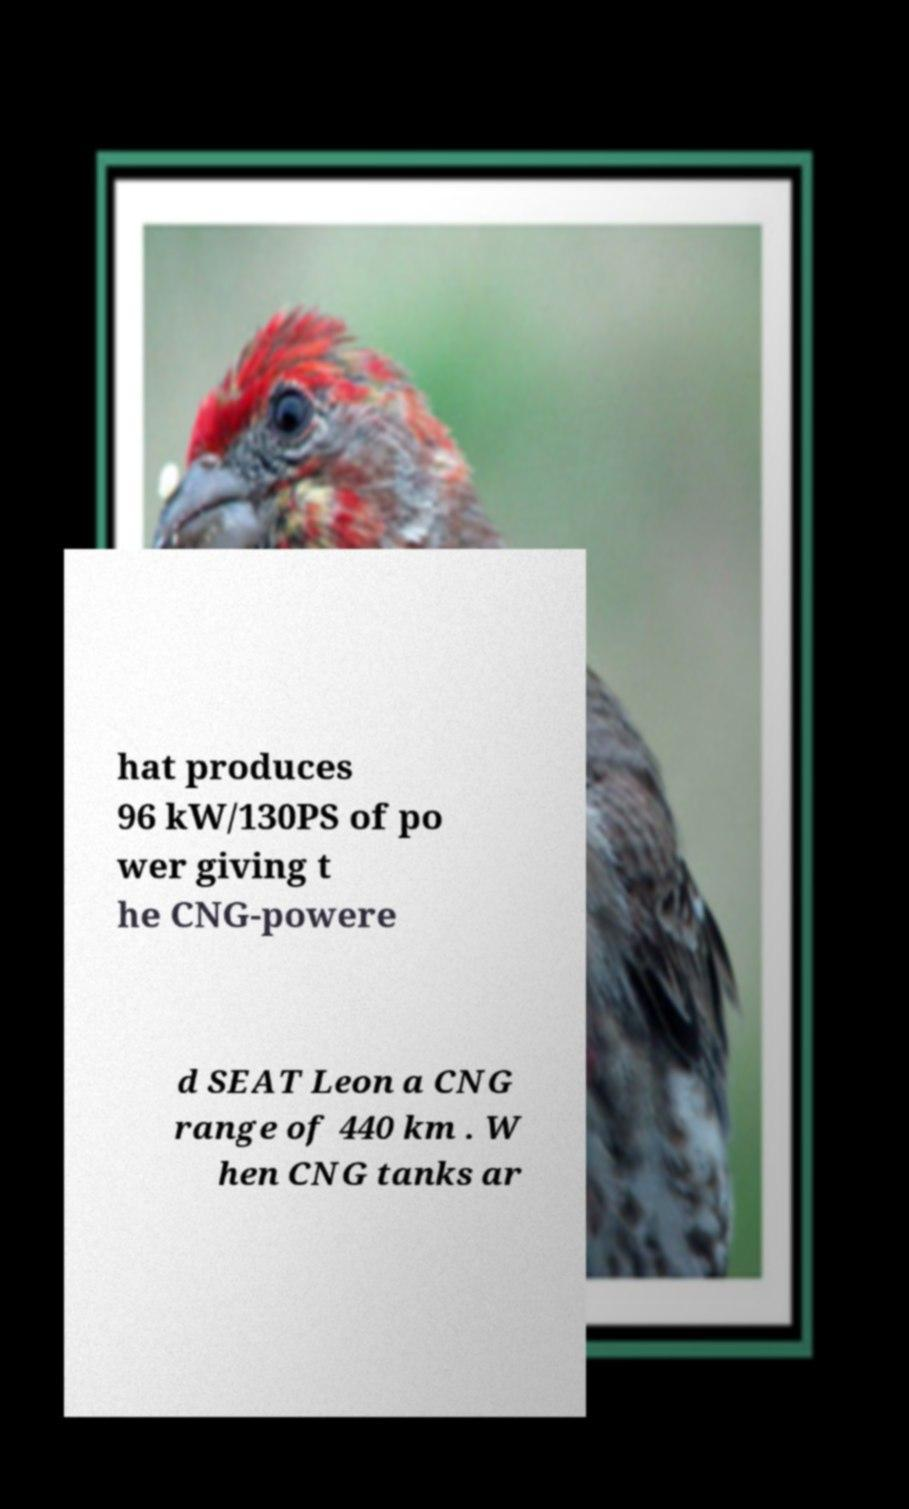Could you extract and type out the text from this image? hat produces 96 kW/130PS of po wer giving t he CNG-powere d SEAT Leon a CNG range of 440 km . W hen CNG tanks ar 